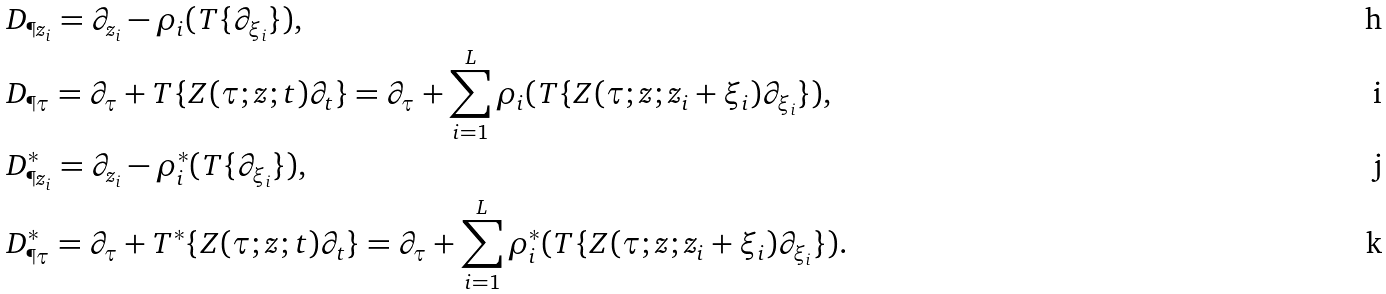Convert formula to latex. <formula><loc_0><loc_0><loc_500><loc_500>& D _ { \P { z _ { i } } } = \partial _ { z _ { i } } - \rho _ { i } ( T \{ \partial _ { \xi _ { i } } \} ) , \\ & D _ { \P { \tau } } = \partial _ { \tau } + T \{ Z ( \tau ; z ; t ) \partial _ { t } \} = \partial _ { \tau } + \sum _ { i = 1 } ^ { L } \rho _ { i } ( T \{ Z ( \tau ; z ; z _ { i } + \xi _ { i } ) \partial _ { \xi _ { i } } \} ) , \\ & D ^ { \ast } _ { \P { z _ { i } } } = \partial _ { z _ { i } } - \rho ^ { \ast } _ { i } ( T \{ \partial _ { \xi _ { i } } \} ) , \\ & D ^ { \ast } _ { \P { \tau } } = \partial _ { \tau } + T ^ { \ast } \{ Z ( \tau ; z ; t ) \partial _ { t } \} = \partial _ { \tau } + \sum _ { i = 1 } ^ { L } \rho ^ { \ast } _ { i } ( T \{ Z ( \tau ; z ; z _ { i } + \xi _ { i } ) \partial _ { \xi _ { i } } \} ) .</formula> 